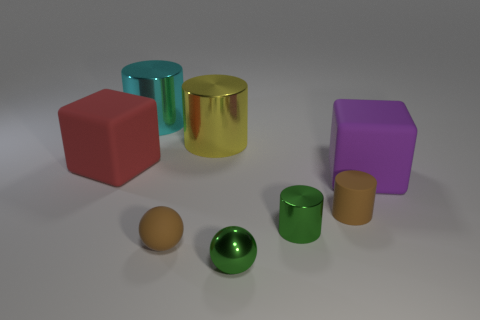There is a cylinder in front of the tiny brown cylinder; is it the same color as the shiny ball?
Provide a succinct answer. Yes. Are there the same number of purple cubes in front of the big cyan cylinder and yellow cylinders that are in front of the small rubber cylinder?
Offer a terse response. No. Are there any other things that have the same material as the red block?
Make the answer very short. Yes. There is a big cylinder left of the brown ball; what color is it?
Offer a terse response. Cyan. Is the number of cylinders that are to the left of the green shiny cylinder the same as the number of red cubes?
Your answer should be very brief. No. How many other objects are the same shape as the cyan shiny object?
Provide a short and direct response. 3. There is a small metal ball; what number of large purple blocks are to the left of it?
Your answer should be compact. 0. There is a rubber object that is both behind the green cylinder and to the left of the brown cylinder; what size is it?
Your response must be concise. Large. Are any brown rubber cylinders visible?
Offer a terse response. Yes. How many other objects are the same size as the brown rubber sphere?
Your answer should be very brief. 3. 